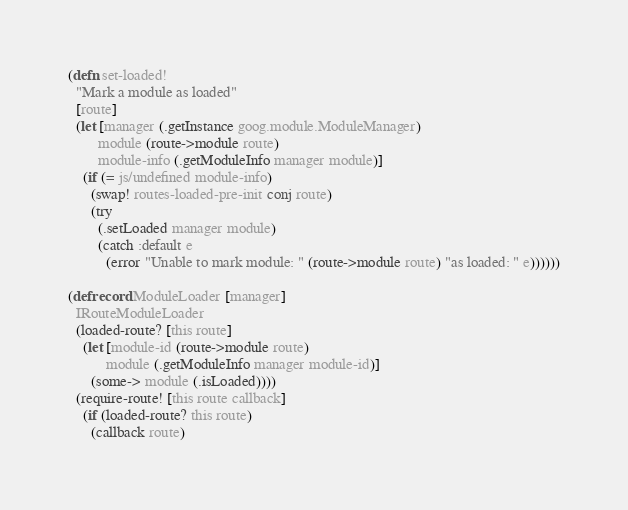<code> <loc_0><loc_0><loc_500><loc_500><_Clojure_>(defn set-loaded!
  "Mark a module as loaded"
  [route]
  (let [manager (.getInstance goog.module.ModuleManager)
        module (route->module route)
        module-info (.getModuleInfo manager module)]
    (if (= js/undefined module-info)
      (swap! routes-loaded-pre-init conj route)
      (try
        (.setLoaded manager module)
        (catch :default e
          (error "Unable to mark module: " (route->module route) "as loaded: " e))))))

(defrecord ModuleLoader [manager]
  IRouteModuleLoader
  (loaded-route? [this route]
    (let [module-id (route->module route)
          module (.getModuleInfo manager module-id)]
      (some-> module (.isLoaded))))
  (require-route! [this route callback]
    (if (loaded-route? this route)
      (callback route)</code> 